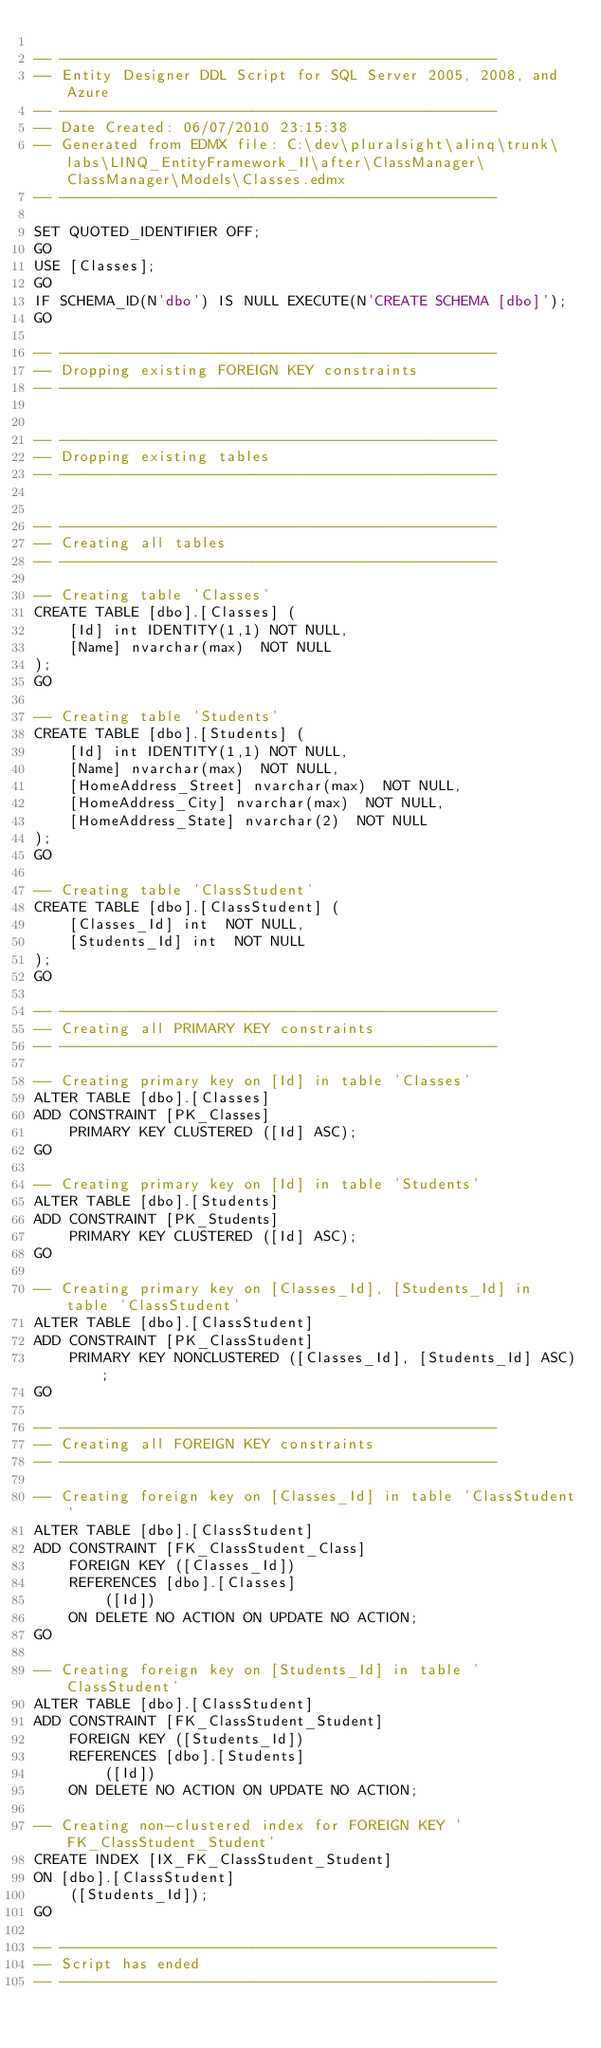Convert code to text. <code><loc_0><loc_0><loc_500><loc_500><_SQL_>
-- --------------------------------------------------
-- Entity Designer DDL Script for SQL Server 2005, 2008, and Azure
-- --------------------------------------------------
-- Date Created: 06/07/2010 23:15:38
-- Generated from EDMX file: C:\dev\pluralsight\alinq\trunk\labs\LINQ_EntityFramework_II\after\ClassManager\ClassManager\Models\Classes.edmx
-- --------------------------------------------------

SET QUOTED_IDENTIFIER OFF;
GO
USE [Classes];
GO
IF SCHEMA_ID(N'dbo') IS NULL EXECUTE(N'CREATE SCHEMA [dbo]');
GO

-- --------------------------------------------------
-- Dropping existing FOREIGN KEY constraints
-- --------------------------------------------------


-- --------------------------------------------------
-- Dropping existing tables
-- --------------------------------------------------


-- --------------------------------------------------
-- Creating all tables
-- --------------------------------------------------

-- Creating table 'Classes'
CREATE TABLE [dbo].[Classes] (
    [Id] int IDENTITY(1,1) NOT NULL,
    [Name] nvarchar(max)  NOT NULL
);
GO

-- Creating table 'Students'
CREATE TABLE [dbo].[Students] (
    [Id] int IDENTITY(1,1) NOT NULL,
    [Name] nvarchar(max)  NOT NULL,
    [HomeAddress_Street] nvarchar(max)  NOT NULL,
    [HomeAddress_City] nvarchar(max)  NOT NULL,
    [HomeAddress_State] nvarchar(2)  NOT NULL
);
GO

-- Creating table 'ClassStudent'
CREATE TABLE [dbo].[ClassStudent] (
    [Classes_Id] int  NOT NULL,
    [Students_Id] int  NOT NULL
);
GO

-- --------------------------------------------------
-- Creating all PRIMARY KEY constraints
-- --------------------------------------------------

-- Creating primary key on [Id] in table 'Classes'
ALTER TABLE [dbo].[Classes]
ADD CONSTRAINT [PK_Classes]
    PRIMARY KEY CLUSTERED ([Id] ASC);
GO

-- Creating primary key on [Id] in table 'Students'
ALTER TABLE [dbo].[Students]
ADD CONSTRAINT [PK_Students]
    PRIMARY KEY CLUSTERED ([Id] ASC);
GO

-- Creating primary key on [Classes_Id], [Students_Id] in table 'ClassStudent'
ALTER TABLE [dbo].[ClassStudent]
ADD CONSTRAINT [PK_ClassStudent]
    PRIMARY KEY NONCLUSTERED ([Classes_Id], [Students_Id] ASC);
GO

-- --------------------------------------------------
-- Creating all FOREIGN KEY constraints
-- --------------------------------------------------

-- Creating foreign key on [Classes_Id] in table 'ClassStudent'
ALTER TABLE [dbo].[ClassStudent]
ADD CONSTRAINT [FK_ClassStudent_Class]
    FOREIGN KEY ([Classes_Id])
    REFERENCES [dbo].[Classes]
        ([Id])
    ON DELETE NO ACTION ON UPDATE NO ACTION;
GO

-- Creating foreign key on [Students_Id] in table 'ClassStudent'
ALTER TABLE [dbo].[ClassStudent]
ADD CONSTRAINT [FK_ClassStudent_Student]
    FOREIGN KEY ([Students_Id])
    REFERENCES [dbo].[Students]
        ([Id])
    ON DELETE NO ACTION ON UPDATE NO ACTION;

-- Creating non-clustered index for FOREIGN KEY 'FK_ClassStudent_Student'
CREATE INDEX [IX_FK_ClassStudent_Student]
ON [dbo].[ClassStudent]
    ([Students_Id]);
GO

-- --------------------------------------------------
-- Script has ended
-- --------------------------------------------------</code> 